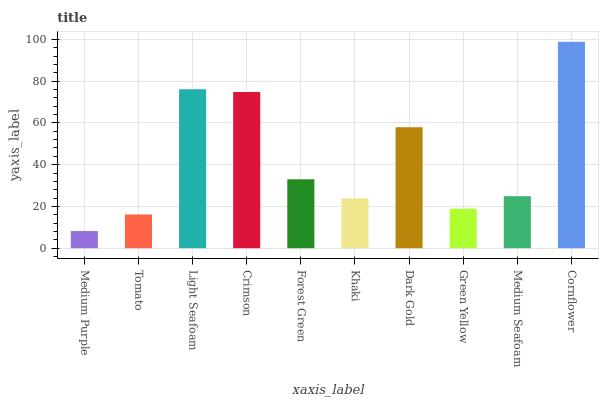Is Tomato the minimum?
Answer yes or no. No. Is Tomato the maximum?
Answer yes or no. No. Is Tomato greater than Medium Purple?
Answer yes or no. Yes. Is Medium Purple less than Tomato?
Answer yes or no. Yes. Is Medium Purple greater than Tomato?
Answer yes or no. No. Is Tomato less than Medium Purple?
Answer yes or no. No. Is Forest Green the high median?
Answer yes or no. Yes. Is Medium Seafoam the low median?
Answer yes or no. Yes. Is Light Seafoam the high median?
Answer yes or no. No. Is Light Seafoam the low median?
Answer yes or no. No. 